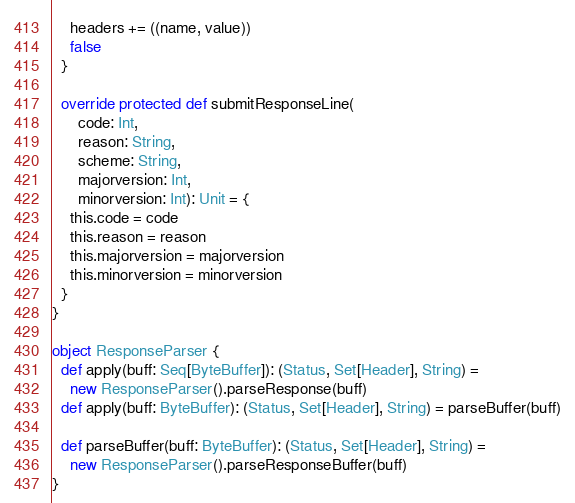Convert code to text. <code><loc_0><loc_0><loc_500><loc_500><_Scala_>    headers += ((name, value))
    false
  }

  override protected def submitResponseLine(
      code: Int,
      reason: String,
      scheme: String,
      majorversion: Int,
      minorversion: Int): Unit = {
    this.code = code
    this.reason = reason
    this.majorversion = majorversion
    this.minorversion = minorversion
  }
}

object ResponseParser {
  def apply(buff: Seq[ByteBuffer]): (Status, Set[Header], String) =
    new ResponseParser().parseResponse(buff)
  def apply(buff: ByteBuffer): (Status, Set[Header], String) = parseBuffer(buff)

  def parseBuffer(buff: ByteBuffer): (Status, Set[Header], String) =
    new ResponseParser().parseResponseBuffer(buff)
}
</code> 